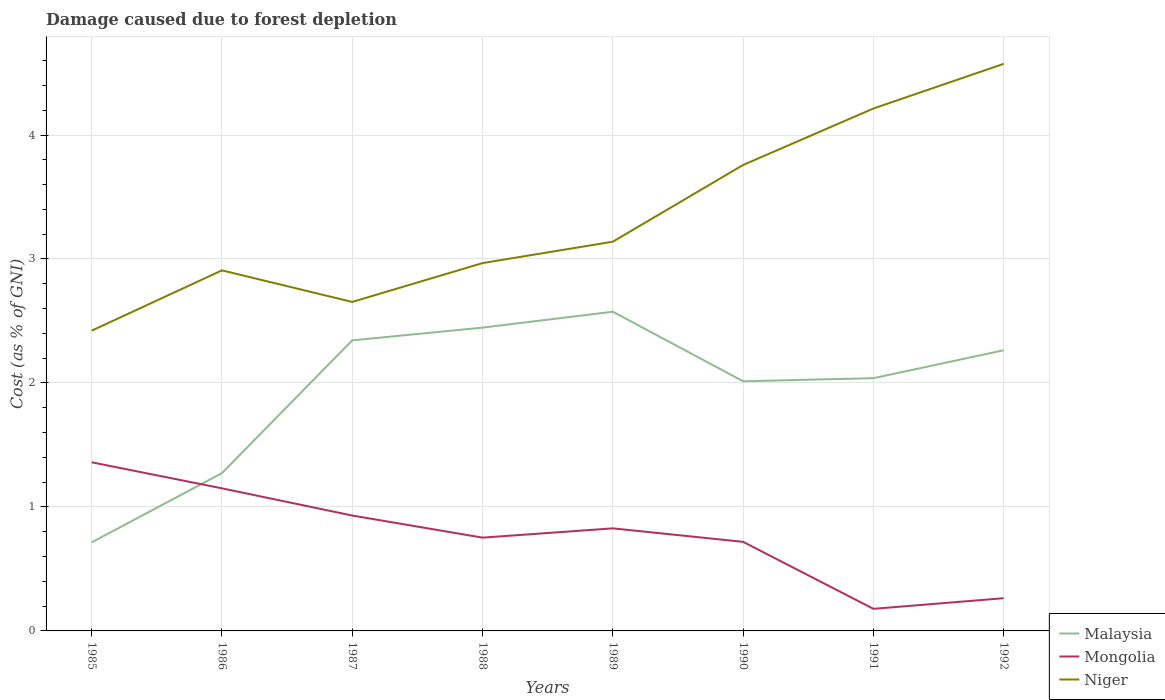How many different coloured lines are there?
Your answer should be compact. 3. Is the number of lines equal to the number of legend labels?
Offer a very short reply. Yes. Across all years, what is the maximum cost of damage caused due to forest depletion in Malaysia?
Offer a very short reply. 0.71. What is the total cost of damage caused due to forest depletion in Niger in the graph?
Provide a short and direct response. -0.06. What is the difference between the highest and the second highest cost of damage caused due to forest depletion in Malaysia?
Offer a very short reply. 1.86. What is the difference between the highest and the lowest cost of damage caused due to forest depletion in Mongolia?
Ensure brevity in your answer.  4. Is the cost of damage caused due to forest depletion in Mongolia strictly greater than the cost of damage caused due to forest depletion in Niger over the years?
Provide a succinct answer. Yes. How many lines are there?
Make the answer very short. 3. Are the values on the major ticks of Y-axis written in scientific E-notation?
Provide a short and direct response. No. Where does the legend appear in the graph?
Ensure brevity in your answer.  Bottom right. What is the title of the graph?
Keep it short and to the point. Damage caused due to forest depletion. What is the label or title of the Y-axis?
Make the answer very short. Cost (as % of GNI). What is the Cost (as % of GNI) in Malaysia in 1985?
Keep it short and to the point. 0.71. What is the Cost (as % of GNI) of Mongolia in 1985?
Keep it short and to the point. 1.36. What is the Cost (as % of GNI) of Niger in 1985?
Provide a succinct answer. 2.42. What is the Cost (as % of GNI) of Malaysia in 1986?
Give a very brief answer. 1.27. What is the Cost (as % of GNI) in Mongolia in 1986?
Ensure brevity in your answer.  1.15. What is the Cost (as % of GNI) of Niger in 1986?
Offer a terse response. 2.91. What is the Cost (as % of GNI) of Malaysia in 1987?
Offer a terse response. 2.34. What is the Cost (as % of GNI) in Mongolia in 1987?
Make the answer very short. 0.93. What is the Cost (as % of GNI) of Niger in 1987?
Offer a very short reply. 2.65. What is the Cost (as % of GNI) in Malaysia in 1988?
Provide a short and direct response. 2.45. What is the Cost (as % of GNI) of Mongolia in 1988?
Provide a short and direct response. 0.75. What is the Cost (as % of GNI) in Niger in 1988?
Offer a very short reply. 2.97. What is the Cost (as % of GNI) in Malaysia in 1989?
Provide a short and direct response. 2.57. What is the Cost (as % of GNI) in Mongolia in 1989?
Make the answer very short. 0.83. What is the Cost (as % of GNI) of Niger in 1989?
Ensure brevity in your answer.  3.14. What is the Cost (as % of GNI) in Malaysia in 1990?
Offer a very short reply. 2.01. What is the Cost (as % of GNI) of Mongolia in 1990?
Your answer should be compact. 0.72. What is the Cost (as % of GNI) of Niger in 1990?
Your answer should be very brief. 3.76. What is the Cost (as % of GNI) in Malaysia in 1991?
Keep it short and to the point. 2.04. What is the Cost (as % of GNI) in Mongolia in 1991?
Offer a terse response. 0.18. What is the Cost (as % of GNI) of Niger in 1991?
Make the answer very short. 4.21. What is the Cost (as % of GNI) of Malaysia in 1992?
Give a very brief answer. 2.26. What is the Cost (as % of GNI) in Mongolia in 1992?
Provide a short and direct response. 0.26. What is the Cost (as % of GNI) of Niger in 1992?
Make the answer very short. 4.57. Across all years, what is the maximum Cost (as % of GNI) of Malaysia?
Provide a short and direct response. 2.57. Across all years, what is the maximum Cost (as % of GNI) of Mongolia?
Your answer should be compact. 1.36. Across all years, what is the maximum Cost (as % of GNI) in Niger?
Provide a succinct answer. 4.57. Across all years, what is the minimum Cost (as % of GNI) in Malaysia?
Your answer should be very brief. 0.71. Across all years, what is the minimum Cost (as % of GNI) in Mongolia?
Your response must be concise. 0.18. Across all years, what is the minimum Cost (as % of GNI) in Niger?
Make the answer very short. 2.42. What is the total Cost (as % of GNI) of Malaysia in the graph?
Keep it short and to the point. 15.67. What is the total Cost (as % of GNI) in Mongolia in the graph?
Ensure brevity in your answer.  6.18. What is the total Cost (as % of GNI) of Niger in the graph?
Provide a short and direct response. 26.64. What is the difference between the Cost (as % of GNI) in Malaysia in 1985 and that in 1986?
Ensure brevity in your answer.  -0.56. What is the difference between the Cost (as % of GNI) of Mongolia in 1985 and that in 1986?
Provide a short and direct response. 0.21. What is the difference between the Cost (as % of GNI) of Niger in 1985 and that in 1986?
Keep it short and to the point. -0.49. What is the difference between the Cost (as % of GNI) in Malaysia in 1985 and that in 1987?
Provide a short and direct response. -1.63. What is the difference between the Cost (as % of GNI) of Mongolia in 1985 and that in 1987?
Provide a succinct answer. 0.43. What is the difference between the Cost (as % of GNI) of Niger in 1985 and that in 1987?
Keep it short and to the point. -0.23. What is the difference between the Cost (as % of GNI) in Malaysia in 1985 and that in 1988?
Ensure brevity in your answer.  -1.73. What is the difference between the Cost (as % of GNI) of Mongolia in 1985 and that in 1988?
Your answer should be compact. 0.61. What is the difference between the Cost (as % of GNI) in Niger in 1985 and that in 1988?
Provide a short and direct response. -0.55. What is the difference between the Cost (as % of GNI) in Malaysia in 1985 and that in 1989?
Give a very brief answer. -1.86. What is the difference between the Cost (as % of GNI) in Mongolia in 1985 and that in 1989?
Your answer should be compact. 0.53. What is the difference between the Cost (as % of GNI) in Niger in 1985 and that in 1989?
Ensure brevity in your answer.  -0.72. What is the difference between the Cost (as % of GNI) of Malaysia in 1985 and that in 1990?
Your response must be concise. -1.3. What is the difference between the Cost (as % of GNI) in Mongolia in 1985 and that in 1990?
Give a very brief answer. 0.64. What is the difference between the Cost (as % of GNI) in Niger in 1985 and that in 1990?
Your response must be concise. -1.34. What is the difference between the Cost (as % of GNI) of Malaysia in 1985 and that in 1991?
Offer a very short reply. -1.32. What is the difference between the Cost (as % of GNI) in Mongolia in 1985 and that in 1991?
Offer a terse response. 1.18. What is the difference between the Cost (as % of GNI) of Niger in 1985 and that in 1991?
Your answer should be very brief. -1.79. What is the difference between the Cost (as % of GNI) in Malaysia in 1985 and that in 1992?
Make the answer very short. -1.55. What is the difference between the Cost (as % of GNI) in Mongolia in 1985 and that in 1992?
Your answer should be very brief. 1.1. What is the difference between the Cost (as % of GNI) in Niger in 1985 and that in 1992?
Ensure brevity in your answer.  -2.15. What is the difference between the Cost (as % of GNI) in Malaysia in 1986 and that in 1987?
Keep it short and to the point. -1.07. What is the difference between the Cost (as % of GNI) of Mongolia in 1986 and that in 1987?
Your answer should be very brief. 0.22. What is the difference between the Cost (as % of GNI) of Niger in 1986 and that in 1987?
Your answer should be very brief. 0.25. What is the difference between the Cost (as % of GNI) in Malaysia in 1986 and that in 1988?
Keep it short and to the point. -1.17. What is the difference between the Cost (as % of GNI) in Mongolia in 1986 and that in 1988?
Offer a very short reply. 0.4. What is the difference between the Cost (as % of GNI) of Niger in 1986 and that in 1988?
Your answer should be very brief. -0.06. What is the difference between the Cost (as % of GNI) of Malaysia in 1986 and that in 1989?
Provide a succinct answer. -1.3. What is the difference between the Cost (as % of GNI) in Mongolia in 1986 and that in 1989?
Keep it short and to the point. 0.32. What is the difference between the Cost (as % of GNI) of Niger in 1986 and that in 1989?
Ensure brevity in your answer.  -0.23. What is the difference between the Cost (as % of GNI) in Malaysia in 1986 and that in 1990?
Offer a very short reply. -0.74. What is the difference between the Cost (as % of GNI) in Mongolia in 1986 and that in 1990?
Offer a very short reply. 0.43. What is the difference between the Cost (as % of GNI) in Niger in 1986 and that in 1990?
Offer a very short reply. -0.85. What is the difference between the Cost (as % of GNI) in Malaysia in 1986 and that in 1991?
Offer a very short reply. -0.77. What is the difference between the Cost (as % of GNI) in Mongolia in 1986 and that in 1991?
Your answer should be compact. 0.97. What is the difference between the Cost (as % of GNI) of Niger in 1986 and that in 1991?
Keep it short and to the point. -1.31. What is the difference between the Cost (as % of GNI) of Malaysia in 1986 and that in 1992?
Give a very brief answer. -0.99. What is the difference between the Cost (as % of GNI) in Mongolia in 1986 and that in 1992?
Make the answer very short. 0.89. What is the difference between the Cost (as % of GNI) in Niger in 1986 and that in 1992?
Your answer should be compact. -1.67. What is the difference between the Cost (as % of GNI) in Malaysia in 1987 and that in 1988?
Keep it short and to the point. -0.1. What is the difference between the Cost (as % of GNI) of Mongolia in 1987 and that in 1988?
Provide a short and direct response. 0.18. What is the difference between the Cost (as % of GNI) of Niger in 1987 and that in 1988?
Give a very brief answer. -0.31. What is the difference between the Cost (as % of GNI) of Malaysia in 1987 and that in 1989?
Offer a terse response. -0.23. What is the difference between the Cost (as % of GNI) in Mongolia in 1987 and that in 1989?
Provide a succinct answer. 0.1. What is the difference between the Cost (as % of GNI) of Niger in 1987 and that in 1989?
Keep it short and to the point. -0.49. What is the difference between the Cost (as % of GNI) of Malaysia in 1987 and that in 1990?
Give a very brief answer. 0.33. What is the difference between the Cost (as % of GNI) in Mongolia in 1987 and that in 1990?
Keep it short and to the point. 0.21. What is the difference between the Cost (as % of GNI) in Niger in 1987 and that in 1990?
Provide a succinct answer. -1.1. What is the difference between the Cost (as % of GNI) of Malaysia in 1987 and that in 1991?
Your answer should be very brief. 0.3. What is the difference between the Cost (as % of GNI) of Mongolia in 1987 and that in 1991?
Keep it short and to the point. 0.75. What is the difference between the Cost (as % of GNI) of Niger in 1987 and that in 1991?
Ensure brevity in your answer.  -1.56. What is the difference between the Cost (as % of GNI) in Malaysia in 1987 and that in 1992?
Your answer should be compact. 0.08. What is the difference between the Cost (as % of GNI) of Mongolia in 1987 and that in 1992?
Make the answer very short. 0.67. What is the difference between the Cost (as % of GNI) in Niger in 1987 and that in 1992?
Provide a short and direct response. -1.92. What is the difference between the Cost (as % of GNI) of Malaysia in 1988 and that in 1989?
Offer a terse response. -0.13. What is the difference between the Cost (as % of GNI) of Mongolia in 1988 and that in 1989?
Ensure brevity in your answer.  -0.07. What is the difference between the Cost (as % of GNI) in Niger in 1988 and that in 1989?
Make the answer very short. -0.17. What is the difference between the Cost (as % of GNI) of Malaysia in 1988 and that in 1990?
Your answer should be compact. 0.43. What is the difference between the Cost (as % of GNI) of Mongolia in 1988 and that in 1990?
Your response must be concise. 0.03. What is the difference between the Cost (as % of GNI) in Niger in 1988 and that in 1990?
Make the answer very short. -0.79. What is the difference between the Cost (as % of GNI) of Malaysia in 1988 and that in 1991?
Provide a succinct answer. 0.41. What is the difference between the Cost (as % of GNI) of Mongolia in 1988 and that in 1991?
Offer a terse response. 0.57. What is the difference between the Cost (as % of GNI) in Niger in 1988 and that in 1991?
Offer a very short reply. -1.25. What is the difference between the Cost (as % of GNI) in Malaysia in 1988 and that in 1992?
Give a very brief answer. 0.18. What is the difference between the Cost (as % of GNI) of Mongolia in 1988 and that in 1992?
Ensure brevity in your answer.  0.49. What is the difference between the Cost (as % of GNI) in Niger in 1988 and that in 1992?
Give a very brief answer. -1.61. What is the difference between the Cost (as % of GNI) of Malaysia in 1989 and that in 1990?
Ensure brevity in your answer.  0.56. What is the difference between the Cost (as % of GNI) in Mongolia in 1989 and that in 1990?
Provide a succinct answer. 0.11. What is the difference between the Cost (as % of GNI) in Niger in 1989 and that in 1990?
Give a very brief answer. -0.62. What is the difference between the Cost (as % of GNI) in Malaysia in 1989 and that in 1991?
Your answer should be very brief. 0.54. What is the difference between the Cost (as % of GNI) in Mongolia in 1989 and that in 1991?
Make the answer very short. 0.65. What is the difference between the Cost (as % of GNI) in Niger in 1989 and that in 1991?
Offer a very short reply. -1.07. What is the difference between the Cost (as % of GNI) in Malaysia in 1989 and that in 1992?
Keep it short and to the point. 0.31. What is the difference between the Cost (as % of GNI) in Mongolia in 1989 and that in 1992?
Your response must be concise. 0.56. What is the difference between the Cost (as % of GNI) of Niger in 1989 and that in 1992?
Your answer should be very brief. -1.43. What is the difference between the Cost (as % of GNI) in Malaysia in 1990 and that in 1991?
Your answer should be very brief. -0.03. What is the difference between the Cost (as % of GNI) in Mongolia in 1990 and that in 1991?
Ensure brevity in your answer.  0.54. What is the difference between the Cost (as % of GNI) of Niger in 1990 and that in 1991?
Offer a very short reply. -0.46. What is the difference between the Cost (as % of GNI) of Malaysia in 1990 and that in 1992?
Your answer should be compact. -0.25. What is the difference between the Cost (as % of GNI) of Mongolia in 1990 and that in 1992?
Your response must be concise. 0.45. What is the difference between the Cost (as % of GNI) of Niger in 1990 and that in 1992?
Offer a very short reply. -0.82. What is the difference between the Cost (as % of GNI) in Malaysia in 1991 and that in 1992?
Ensure brevity in your answer.  -0.23. What is the difference between the Cost (as % of GNI) of Mongolia in 1991 and that in 1992?
Offer a very short reply. -0.09. What is the difference between the Cost (as % of GNI) in Niger in 1991 and that in 1992?
Your response must be concise. -0.36. What is the difference between the Cost (as % of GNI) in Malaysia in 1985 and the Cost (as % of GNI) in Mongolia in 1986?
Provide a short and direct response. -0.44. What is the difference between the Cost (as % of GNI) of Malaysia in 1985 and the Cost (as % of GNI) of Niger in 1986?
Give a very brief answer. -2.19. What is the difference between the Cost (as % of GNI) of Mongolia in 1985 and the Cost (as % of GNI) of Niger in 1986?
Keep it short and to the point. -1.55. What is the difference between the Cost (as % of GNI) in Malaysia in 1985 and the Cost (as % of GNI) in Mongolia in 1987?
Your answer should be very brief. -0.22. What is the difference between the Cost (as % of GNI) in Malaysia in 1985 and the Cost (as % of GNI) in Niger in 1987?
Your response must be concise. -1.94. What is the difference between the Cost (as % of GNI) of Mongolia in 1985 and the Cost (as % of GNI) of Niger in 1987?
Your answer should be very brief. -1.29. What is the difference between the Cost (as % of GNI) of Malaysia in 1985 and the Cost (as % of GNI) of Mongolia in 1988?
Offer a terse response. -0.04. What is the difference between the Cost (as % of GNI) in Malaysia in 1985 and the Cost (as % of GNI) in Niger in 1988?
Make the answer very short. -2.25. What is the difference between the Cost (as % of GNI) in Mongolia in 1985 and the Cost (as % of GNI) in Niger in 1988?
Your response must be concise. -1.61. What is the difference between the Cost (as % of GNI) of Malaysia in 1985 and the Cost (as % of GNI) of Mongolia in 1989?
Provide a short and direct response. -0.11. What is the difference between the Cost (as % of GNI) in Malaysia in 1985 and the Cost (as % of GNI) in Niger in 1989?
Offer a very short reply. -2.43. What is the difference between the Cost (as % of GNI) of Mongolia in 1985 and the Cost (as % of GNI) of Niger in 1989?
Your response must be concise. -1.78. What is the difference between the Cost (as % of GNI) in Malaysia in 1985 and the Cost (as % of GNI) in Mongolia in 1990?
Your answer should be compact. -0. What is the difference between the Cost (as % of GNI) of Malaysia in 1985 and the Cost (as % of GNI) of Niger in 1990?
Your response must be concise. -3.04. What is the difference between the Cost (as % of GNI) of Mongolia in 1985 and the Cost (as % of GNI) of Niger in 1990?
Offer a terse response. -2.4. What is the difference between the Cost (as % of GNI) in Malaysia in 1985 and the Cost (as % of GNI) in Mongolia in 1991?
Your answer should be compact. 0.54. What is the difference between the Cost (as % of GNI) in Malaysia in 1985 and the Cost (as % of GNI) in Niger in 1991?
Give a very brief answer. -3.5. What is the difference between the Cost (as % of GNI) of Mongolia in 1985 and the Cost (as % of GNI) of Niger in 1991?
Your response must be concise. -2.85. What is the difference between the Cost (as % of GNI) of Malaysia in 1985 and the Cost (as % of GNI) of Mongolia in 1992?
Ensure brevity in your answer.  0.45. What is the difference between the Cost (as % of GNI) of Malaysia in 1985 and the Cost (as % of GNI) of Niger in 1992?
Provide a short and direct response. -3.86. What is the difference between the Cost (as % of GNI) of Mongolia in 1985 and the Cost (as % of GNI) of Niger in 1992?
Your answer should be very brief. -3.21. What is the difference between the Cost (as % of GNI) in Malaysia in 1986 and the Cost (as % of GNI) in Mongolia in 1987?
Offer a terse response. 0.34. What is the difference between the Cost (as % of GNI) in Malaysia in 1986 and the Cost (as % of GNI) in Niger in 1987?
Ensure brevity in your answer.  -1.38. What is the difference between the Cost (as % of GNI) in Mongolia in 1986 and the Cost (as % of GNI) in Niger in 1987?
Your response must be concise. -1.5. What is the difference between the Cost (as % of GNI) of Malaysia in 1986 and the Cost (as % of GNI) of Mongolia in 1988?
Your answer should be compact. 0.52. What is the difference between the Cost (as % of GNI) of Malaysia in 1986 and the Cost (as % of GNI) of Niger in 1988?
Make the answer very short. -1.69. What is the difference between the Cost (as % of GNI) of Mongolia in 1986 and the Cost (as % of GNI) of Niger in 1988?
Offer a terse response. -1.82. What is the difference between the Cost (as % of GNI) in Malaysia in 1986 and the Cost (as % of GNI) in Mongolia in 1989?
Provide a short and direct response. 0.45. What is the difference between the Cost (as % of GNI) of Malaysia in 1986 and the Cost (as % of GNI) of Niger in 1989?
Your answer should be compact. -1.87. What is the difference between the Cost (as % of GNI) of Mongolia in 1986 and the Cost (as % of GNI) of Niger in 1989?
Keep it short and to the point. -1.99. What is the difference between the Cost (as % of GNI) of Malaysia in 1986 and the Cost (as % of GNI) of Mongolia in 1990?
Your response must be concise. 0.55. What is the difference between the Cost (as % of GNI) of Malaysia in 1986 and the Cost (as % of GNI) of Niger in 1990?
Your response must be concise. -2.49. What is the difference between the Cost (as % of GNI) of Mongolia in 1986 and the Cost (as % of GNI) of Niger in 1990?
Your answer should be very brief. -2.61. What is the difference between the Cost (as % of GNI) in Malaysia in 1986 and the Cost (as % of GNI) in Mongolia in 1991?
Ensure brevity in your answer.  1.09. What is the difference between the Cost (as % of GNI) of Malaysia in 1986 and the Cost (as % of GNI) of Niger in 1991?
Ensure brevity in your answer.  -2.94. What is the difference between the Cost (as % of GNI) of Mongolia in 1986 and the Cost (as % of GNI) of Niger in 1991?
Provide a short and direct response. -3.06. What is the difference between the Cost (as % of GNI) in Malaysia in 1986 and the Cost (as % of GNI) in Mongolia in 1992?
Your answer should be very brief. 1.01. What is the difference between the Cost (as % of GNI) of Malaysia in 1986 and the Cost (as % of GNI) of Niger in 1992?
Your response must be concise. -3.3. What is the difference between the Cost (as % of GNI) of Mongolia in 1986 and the Cost (as % of GNI) of Niger in 1992?
Your answer should be very brief. -3.42. What is the difference between the Cost (as % of GNI) in Malaysia in 1987 and the Cost (as % of GNI) in Mongolia in 1988?
Your response must be concise. 1.59. What is the difference between the Cost (as % of GNI) of Malaysia in 1987 and the Cost (as % of GNI) of Niger in 1988?
Ensure brevity in your answer.  -0.62. What is the difference between the Cost (as % of GNI) of Mongolia in 1987 and the Cost (as % of GNI) of Niger in 1988?
Provide a short and direct response. -2.04. What is the difference between the Cost (as % of GNI) in Malaysia in 1987 and the Cost (as % of GNI) in Mongolia in 1989?
Keep it short and to the point. 1.52. What is the difference between the Cost (as % of GNI) of Malaysia in 1987 and the Cost (as % of GNI) of Niger in 1989?
Give a very brief answer. -0.8. What is the difference between the Cost (as % of GNI) in Mongolia in 1987 and the Cost (as % of GNI) in Niger in 1989?
Ensure brevity in your answer.  -2.21. What is the difference between the Cost (as % of GNI) of Malaysia in 1987 and the Cost (as % of GNI) of Mongolia in 1990?
Your answer should be compact. 1.63. What is the difference between the Cost (as % of GNI) of Malaysia in 1987 and the Cost (as % of GNI) of Niger in 1990?
Offer a very short reply. -1.41. What is the difference between the Cost (as % of GNI) of Mongolia in 1987 and the Cost (as % of GNI) of Niger in 1990?
Your answer should be very brief. -2.83. What is the difference between the Cost (as % of GNI) in Malaysia in 1987 and the Cost (as % of GNI) in Mongolia in 1991?
Ensure brevity in your answer.  2.17. What is the difference between the Cost (as % of GNI) in Malaysia in 1987 and the Cost (as % of GNI) in Niger in 1991?
Offer a terse response. -1.87. What is the difference between the Cost (as % of GNI) of Mongolia in 1987 and the Cost (as % of GNI) of Niger in 1991?
Provide a short and direct response. -3.28. What is the difference between the Cost (as % of GNI) of Malaysia in 1987 and the Cost (as % of GNI) of Mongolia in 1992?
Offer a terse response. 2.08. What is the difference between the Cost (as % of GNI) of Malaysia in 1987 and the Cost (as % of GNI) of Niger in 1992?
Offer a terse response. -2.23. What is the difference between the Cost (as % of GNI) in Mongolia in 1987 and the Cost (as % of GNI) in Niger in 1992?
Your answer should be very brief. -3.64. What is the difference between the Cost (as % of GNI) of Malaysia in 1988 and the Cost (as % of GNI) of Mongolia in 1989?
Offer a very short reply. 1.62. What is the difference between the Cost (as % of GNI) of Malaysia in 1988 and the Cost (as % of GNI) of Niger in 1989?
Your answer should be very brief. -0.69. What is the difference between the Cost (as % of GNI) of Mongolia in 1988 and the Cost (as % of GNI) of Niger in 1989?
Your response must be concise. -2.39. What is the difference between the Cost (as % of GNI) in Malaysia in 1988 and the Cost (as % of GNI) in Mongolia in 1990?
Provide a succinct answer. 1.73. What is the difference between the Cost (as % of GNI) of Malaysia in 1988 and the Cost (as % of GNI) of Niger in 1990?
Keep it short and to the point. -1.31. What is the difference between the Cost (as % of GNI) in Mongolia in 1988 and the Cost (as % of GNI) in Niger in 1990?
Give a very brief answer. -3.01. What is the difference between the Cost (as % of GNI) in Malaysia in 1988 and the Cost (as % of GNI) in Mongolia in 1991?
Provide a succinct answer. 2.27. What is the difference between the Cost (as % of GNI) in Malaysia in 1988 and the Cost (as % of GNI) in Niger in 1991?
Provide a short and direct response. -1.77. What is the difference between the Cost (as % of GNI) in Mongolia in 1988 and the Cost (as % of GNI) in Niger in 1991?
Keep it short and to the point. -3.46. What is the difference between the Cost (as % of GNI) of Malaysia in 1988 and the Cost (as % of GNI) of Mongolia in 1992?
Give a very brief answer. 2.18. What is the difference between the Cost (as % of GNI) of Malaysia in 1988 and the Cost (as % of GNI) of Niger in 1992?
Make the answer very short. -2.13. What is the difference between the Cost (as % of GNI) in Mongolia in 1988 and the Cost (as % of GNI) in Niger in 1992?
Provide a short and direct response. -3.82. What is the difference between the Cost (as % of GNI) of Malaysia in 1989 and the Cost (as % of GNI) of Mongolia in 1990?
Give a very brief answer. 1.86. What is the difference between the Cost (as % of GNI) of Malaysia in 1989 and the Cost (as % of GNI) of Niger in 1990?
Your answer should be very brief. -1.18. What is the difference between the Cost (as % of GNI) of Mongolia in 1989 and the Cost (as % of GNI) of Niger in 1990?
Provide a succinct answer. -2.93. What is the difference between the Cost (as % of GNI) of Malaysia in 1989 and the Cost (as % of GNI) of Mongolia in 1991?
Offer a terse response. 2.4. What is the difference between the Cost (as % of GNI) of Malaysia in 1989 and the Cost (as % of GNI) of Niger in 1991?
Give a very brief answer. -1.64. What is the difference between the Cost (as % of GNI) of Mongolia in 1989 and the Cost (as % of GNI) of Niger in 1991?
Keep it short and to the point. -3.39. What is the difference between the Cost (as % of GNI) of Malaysia in 1989 and the Cost (as % of GNI) of Mongolia in 1992?
Offer a very short reply. 2.31. What is the difference between the Cost (as % of GNI) in Malaysia in 1989 and the Cost (as % of GNI) in Niger in 1992?
Ensure brevity in your answer.  -2. What is the difference between the Cost (as % of GNI) in Mongolia in 1989 and the Cost (as % of GNI) in Niger in 1992?
Give a very brief answer. -3.75. What is the difference between the Cost (as % of GNI) in Malaysia in 1990 and the Cost (as % of GNI) in Mongolia in 1991?
Keep it short and to the point. 1.84. What is the difference between the Cost (as % of GNI) in Malaysia in 1990 and the Cost (as % of GNI) in Niger in 1991?
Keep it short and to the point. -2.2. What is the difference between the Cost (as % of GNI) in Mongolia in 1990 and the Cost (as % of GNI) in Niger in 1991?
Your answer should be compact. -3.5. What is the difference between the Cost (as % of GNI) in Malaysia in 1990 and the Cost (as % of GNI) in Mongolia in 1992?
Make the answer very short. 1.75. What is the difference between the Cost (as % of GNI) of Malaysia in 1990 and the Cost (as % of GNI) of Niger in 1992?
Ensure brevity in your answer.  -2.56. What is the difference between the Cost (as % of GNI) in Mongolia in 1990 and the Cost (as % of GNI) in Niger in 1992?
Keep it short and to the point. -3.86. What is the difference between the Cost (as % of GNI) of Malaysia in 1991 and the Cost (as % of GNI) of Mongolia in 1992?
Keep it short and to the point. 1.77. What is the difference between the Cost (as % of GNI) in Malaysia in 1991 and the Cost (as % of GNI) in Niger in 1992?
Provide a succinct answer. -2.54. What is the difference between the Cost (as % of GNI) of Mongolia in 1991 and the Cost (as % of GNI) of Niger in 1992?
Your response must be concise. -4.4. What is the average Cost (as % of GNI) of Malaysia per year?
Keep it short and to the point. 1.96. What is the average Cost (as % of GNI) in Mongolia per year?
Give a very brief answer. 0.77. What is the average Cost (as % of GNI) of Niger per year?
Your response must be concise. 3.33. In the year 1985, what is the difference between the Cost (as % of GNI) of Malaysia and Cost (as % of GNI) of Mongolia?
Keep it short and to the point. -0.65. In the year 1985, what is the difference between the Cost (as % of GNI) in Malaysia and Cost (as % of GNI) in Niger?
Provide a short and direct response. -1.71. In the year 1985, what is the difference between the Cost (as % of GNI) in Mongolia and Cost (as % of GNI) in Niger?
Your response must be concise. -1.06. In the year 1986, what is the difference between the Cost (as % of GNI) in Malaysia and Cost (as % of GNI) in Mongolia?
Your answer should be very brief. 0.12. In the year 1986, what is the difference between the Cost (as % of GNI) of Malaysia and Cost (as % of GNI) of Niger?
Offer a very short reply. -1.64. In the year 1986, what is the difference between the Cost (as % of GNI) in Mongolia and Cost (as % of GNI) in Niger?
Your answer should be compact. -1.76. In the year 1987, what is the difference between the Cost (as % of GNI) in Malaysia and Cost (as % of GNI) in Mongolia?
Keep it short and to the point. 1.41. In the year 1987, what is the difference between the Cost (as % of GNI) in Malaysia and Cost (as % of GNI) in Niger?
Your answer should be very brief. -0.31. In the year 1987, what is the difference between the Cost (as % of GNI) of Mongolia and Cost (as % of GNI) of Niger?
Your response must be concise. -1.72. In the year 1988, what is the difference between the Cost (as % of GNI) in Malaysia and Cost (as % of GNI) in Mongolia?
Provide a succinct answer. 1.69. In the year 1988, what is the difference between the Cost (as % of GNI) in Malaysia and Cost (as % of GNI) in Niger?
Offer a terse response. -0.52. In the year 1988, what is the difference between the Cost (as % of GNI) of Mongolia and Cost (as % of GNI) of Niger?
Provide a short and direct response. -2.21. In the year 1989, what is the difference between the Cost (as % of GNI) in Malaysia and Cost (as % of GNI) in Mongolia?
Make the answer very short. 1.75. In the year 1989, what is the difference between the Cost (as % of GNI) in Malaysia and Cost (as % of GNI) in Niger?
Give a very brief answer. -0.56. In the year 1989, what is the difference between the Cost (as % of GNI) of Mongolia and Cost (as % of GNI) of Niger?
Offer a terse response. -2.31. In the year 1990, what is the difference between the Cost (as % of GNI) in Malaysia and Cost (as % of GNI) in Mongolia?
Provide a succinct answer. 1.3. In the year 1990, what is the difference between the Cost (as % of GNI) of Malaysia and Cost (as % of GNI) of Niger?
Ensure brevity in your answer.  -1.74. In the year 1990, what is the difference between the Cost (as % of GNI) in Mongolia and Cost (as % of GNI) in Niger?
Provide a short and direct response. -3.04. In the year 1991, what is the difference between the Cost (as % of GNI) in Malaysia and Cost (as % of GNI) in Mongolia?
Provide a short and direct response. 1.86. In the year 1991, what is the difference between the Cost (as % of GNI) in Malaysia and Cost (as % of GNI) in Niger?
Your answer should be compact. -2.18. In the year 1991, what is the difference between the Cost (as % of GNI) of Mongolia and Cost (as % of GNI) of Niger?
Offer a terse response. -4.04. In the year 1992, what is the difference between the Cost (as % of GNI) in Malaysia and Cost (as % of GNI) in Niger?
Your answer should be compact. -2.31. In the year 1992, what is the difference between the Cost (as % of GNI) in Mongolia and Cost (as % of GNI) in Niger?
Offer a terse response. -4.31. What is the ratio of the Cost (as % of GNI) in Malaysia in 1985 to that in 1986?
Your answer should be very brief. 0.56. What is the ratio of the Cost (as % of GNI) in Mongolia in 1985 to that in 1986?
Offer a terse response. 1.18. What is the ratio of the Cost (as % of GNI) of Niger in 1985 to that in 1986?
Provide a succinct answer. 0.83. What is the ratio of the Cost (as % of GNI) of Malaysia in 1985 to that in 1987?
Your answer should be compact. 0.3. What is the ratio of the Cost (as % of GNI) in Mongolia in 1985 to that in 1987?
Give a very brief answer. 1.46. What is the ratio of the Cost (as % of GNI) in Niger in 1985 to that in 1987?
Your answer should be very brief. 0.91. What is the ratio of the Cost (as % of GNI) of Malaysia in 1985 to that in 1988?
Your answer should be compact. 0.29. What is the ratio of the Cost (as % of GNI) of Mongolia in 1985 to that in 1988?
Ensure brevity in your answer.  1.81. What is the ratio of the Cost (as % of GNI) of Niger in 1985 to that in 1988?
Ensure brevity in your answer.  0.82. What is the ratio of the Cost (as % of GNI) in Malaysia in 1985 to that in 1989?
Provide a short and direct response. 0.28. What is the ratio of the Cost (as % of GNI) in Mongolia in 1985 to that in 1989?
Ensure brevity in your answer.  1.64. What is the ratio of the Cost (as % of GNI) in Niger in 1985 to that in 1989?
Your answer should be compact. 0.77. What is the ratio of the Cost (as % of GNI) of Malaysia in 1985 to that in 1990?
Your response must be concise. 0.35. What is the ratio of the Cost (as % of GNI) in Mongolia in 1985 to that in 1990?
Make the answer very short. 1.89. What is the ratio of the Cost (as % of GNI) of Niger in 1985 to that in 1990?
Your response must be concise. 0.64. What is the ratio of the Cost (as % of GNI) in Malaysia in 1985 to that in 1991?
Keep it short and to the point. 0.35. What is the ratio of the Cost (as % of GNI) in Mongolia in 1985 to that in 1991?
Your answer should be very brief. 7.64. What is the ratio of the Cost (as % of GNI) of Niger in 1985 to that in 1991?
Ensure brevity in your answer.  0.57. What is the ratio of the Cost (as % of GNI) in Malaysia in 1985 to that in 1992?
Your answer should be very brief. 0.32. What is the ratio of the Cost (as % of GNI) of Mongolia in 1985 to that in 1992?
Keep it short and to the point. 5.15. What is the ratio of the Cost (as % of GNI) in Niger in 1985 to that in 1992?
Provide a succinct answer. 0.53. What is the ratio of the Cost (as % of GNI) in Malaysia in 1986 to that in 1987?
Provide a short and direct response. 0.54. What is the ratio of the Cost (as % of GNI) in Mongolia in 1986 to that in 1987?
Keep it short and to the point. 1.24. What is the ratio of the Cost (as % of GNI) in Niger in 1986 to that in 1987?
Offer a very short reply. 1.1. What is the ratio of the Cost (as % of GNI) of Malaysia in 1986 to that in 1988?
Keep it short and to the point. 0.52. What is the ratio of the Cost (as % of GNI) of Mongolia in 1986 to that in 1988?
Your response must be concise. 1.53. What is the ratio of the Cost (as % of GNI) in Niger in 1986 to that in 1988?
Ensure brevity in your answer.  0.98. What is the ratio of the Cost (as % of GNI) in Malaysia in 1986 to that in 1989?
Provide a succinct answer. 0.49. What is the ratio of the Cost (as % of GNI) of Mongolia in 1986 to that in 1989?
Provide a succinct answer. 1.39. What is the ratio of the Cost (as % of GNI) in Niger in 1986 to that in 1989?
Your answer should be compact. 0.93. What is the ratio of the Cost (as % of GNI) in Malaysia in 1986 to that in 1990?
Provide a short and direct response. 0.63. What is the ratio of the Cost (as % of GNI) in Mongolia in 1986 to that in 1990?
Your answer should be very brief. 1.6. What is the ratio of the Cost (as % of GNI) in Niger in 1986 to that in 1990?
Your answer should be very brief. 0.77. What is the ratio of the Cost (as % of GNI) of Malaysia in 1986 to that in 1991?
Provide a succinct answer. 0.62. What is the ratio of the Cost (as % of GNI) of Mongolia in 1986 to that in 1991?
Keep it short and to the point. 6.46. What is the ratio of the Cost (as % of GNI) of Niger in 1986 to that in 1991?
Ensure brevity in your answer.  0.69. What is the ratio of the Cost (as % of GNI) of Malaysia in 1986 to that in 1992?
Offer a very short reply. 0.56. What is the ratio of the Cost (as % of GNI) in Mongolia in 1986 to that in 1992?
Ensure brevity in your answer.  4.36. What is the ratio of the Cost (as % of GNI) in Niger in 1986 to that in 1992?
Your response must be concise. 0.64. What is the ratio of the Cost (as % of GNI) of Malaysia in 1987 to that in 1988?
Provide a short and direct response. 0.96. What is the ratio of the Cost (as % of GNI) of Mongolia in 1987 to that in 1988?
Offer a very short reply. 1.24. What is the ratio of the Cost (as % of GNI) of Niger in 1987 to that in 1988?
Keep it short and to the point. 0.89. What is the ratio of the Cost (as % of GNI) in Malaysia in 1987 to that in 1989?
Provide a short and direct response. 0.91. What is the ratio of the Cost (as % of GNI) of Mongolia in 1987 to that in 1989?
Your response must be concise. 1.13. What is the ratio of the Cost (as % of GNI) in Niger in 1987 to that in 1989?
Keep it short and to the point. 0.85. What is the ratio of the Cost (as % of GNI) of Malaysia in 1987 to that in 1990?
Your response must be concise. 1.16. What is the ratio of the Cost (as % of GNI) in Mongolia in 1987 to that in 1990?
Ensure brevity in your answer.  1.3. What is the ratio of the Cost (as % of GNI) in Niger in 1987 to that in 1990?
Provide a short and direct response. 0.71. What is the ratio of the Cost (as % of GNI) of Malaysia in 1987 to that in 1991?
Offer a terse response. 1.15. What is the ratio of the Cost (as % of GNI) in Mongolia in 1987 to that in 1991?
Offer a terse response. 5.23. What is the ratio of the Cost (as % of GNI) in Niger in 1987 to that in 1991?
Offer a terse response. 0.63. What is the ratio of the Cost (as % of GNI) in Malaysia in 1987 to that in 1992?
Provide a succinct answer. 1.04. What is the ratio of the Cost (as % of GNI) in Mongolia in 1987 to that in 1992?
Keep it short and to the point. 3.53. What is the ratio of the Cost (as % of GNI) in Niger in 1987 to that in 1992?
Offer a terse response. 0.58. What is the ratio of the Cost (as % of GNI) of Malaysia in 1988 to that in 1989?
Provide a succinct answer. 0.95. What is the ratio of the Cost (as % of GNI) in Mongolia in 1988 to that in 1989?
Keep it short and to the point. 0.91. What is the ratio of the Cost (as % of GNI) of Niger in 1988 to that in 1989?
Your answer should be very brief. 0.94. What is the ratio of the Cost (as % of GNI) of Malaysia in 1988 to that in 1990?
Ensure brevity in your answer.  1.21. What is the ratio of the Cost (as % of GNI) of Mongolia in 1988 to that in 1990?
Ensure brevity in your answer.  1.05. What is the ratio of the Cost (as % of GNI) of Niger in 1988 to that in 1990?
Your response must be concise. 0.79. What is the ratio of the Cost (as % of GNI) of Mongolia in 1988 to that in 1991?
Give a very brief answer. 4.22. What is the ratio of the Cost (as % of GNI) in Niger in 1988 to that in 1991?
Your answer should be compact. 0.7. What is the ratio of the Cost (as % of GNI) in Malaysia in 1988 to that in 1992?
Keep it short and to the point. 1.08. What is the ratio of the Cost (as % of GNI) of Mongolia in 1988 to that in 1992?
Offer a very short reply. 2.85. What is the ratio of the Cost (as % of GNI) in Niger in 1988 to that in 1992?
Your answer should be very brief. 0.65. What is the ratio of the Cost (as % of GNI) in Malaysia in 1989 to that in 1990?
Make the answer very short. 1.28. What is the ratio of the Cost (as % of GNI) in Mongolia in 1989 to that in 1990?
Your response must be concise. 1.15. What is the ratio of the Cost (as % of GNI) of Niger in 1989 to that in 1990?
Offer a terse response. 0.84. What is the ratio of the Cost (as % of GNI) in Malaysia in 1989 to that in 1991?
Your answer should be very brief. 1.26. What is the ratio of the Cost (as % of GNI) of Mongolia in 1989 to that in 1991?
Keep it short and to the point. 4.64. What is the ratio of the Cost (as % of GNI) of Niger in 1989 to that in 1991?
Offer a terse response. 0.75. What is the ratio of the Cost (as % of GNI) in Malaysia in 1989 to that in 1992?
Ensure brevity in your answer.  1.14. What is the ratio of the Cost (as % of GNI) of Mongolia in 1989 to that in 1992?
Offer a terse response. 3.13. What is the ratio of the Cost (as % of GNI) in Niger in 1989 to that in 1992?
Provide a succinct answer. 0.69. What is the ratio of the Cost (as % of GNI) of Mongolia in 1990 to that in 1991?
Your response must be concise. 4.03. What is the ratio of the Cost (as % of GNI) in Niger in 1990 to that in 1991?
Provide a short and direct response. 0.89. What is the ratio of the Cost (as % of GNI) of Malaysia in 1990 to that in 1992?
Offer a very short reply. 0.89. What is the ratio of the Cost (as % of GNI) of Mongolia in 1990 to that in 1992?
Keep it short and to the point. 2.72. What is the ratio of the Cost (as % of GNI) in Niger in 1990 to that in 1992?
Offer a very short reply. 0.82. What is the ratio of the Cost (as % of GNI) in Malaysia in 1991 to that in 1992?
Your answer should be very brief. 0.9. What is the ratio of the Cost (as % of GNI) of Mongolia in 1991 to that in 1992?
Keep it short and to the point. 0.67. What is the ratio of the Cost (as % of GNI) of Niger in 1991 to that in 1992?
Make the answer very short. 0.92. What is the difference between the highest and the second highest Cost (as % of GNI) in Malaysia?
Make the answer very short. 0.13. What is the difference between the highest and the second highest Cost (as % of GNI) in Mongolia?
Your answer should be compact. 0.21. What is the difference between the highest and the second highest Cost (as % of GNI) of Niger?
Make the answer very short. 0.36. What is the difference between the highest and the lowest Cost (as % of GNI) in Malaysia?
Make the answer very short. 1.86. What is the difference between the highest and the lowest Cost (as % of GNI) of Mongolia?
Your answer should be very brief. 1.18. What is the difference between the highest and the lowest Cost (as % of GNI) of Niger?
Offer a very short reply. 2.15. 